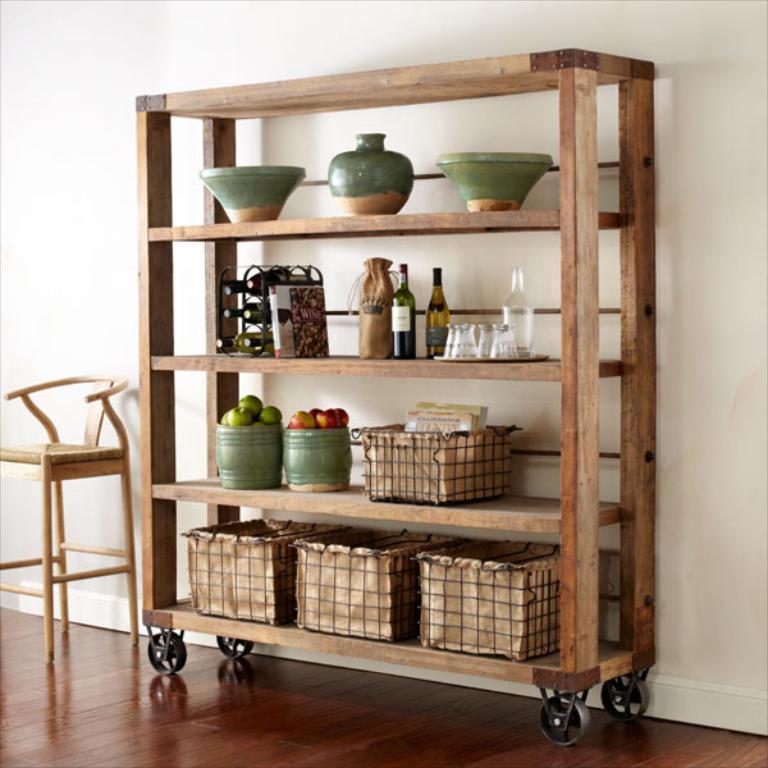In one or two sentences, can you explain what this image depicts? In the center of the picture there is a wooden shelf, in the shelf there are baskets, jars, bottles, glasses, fruits, books and other objects. On the left there is a chair. In the foreground it is floor. In the background it is wall painted white. 